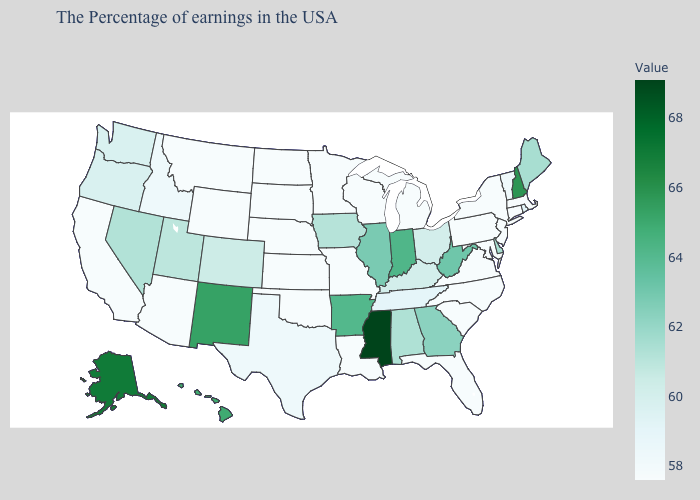Does Illinois have the lowest value in the USA?
Give a very brief answer. No. Does Nebraska have the highest value in the MidWest?
Keep it brief. No. Which states have the lowest value in the USA?
Answer briefly. Massachusetts, Connecticut, New York, New Jersey, Maryland, Pennsylvania, Virginia, North Carolina, South Carolina, Florida, Michigan, Wisconsin, Louisiana, Missouri, Minnesota, Kansas, Nebraska, Oklahoma, South Dakota, North Dakota, Wyoming, Montana, Arizona, California. 